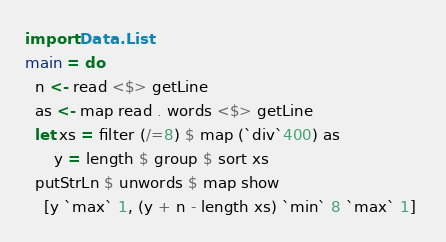Convert code to text. <code><loc_0><loc_0><loc_500><loc_500><_Haskell_>import Data.List
main = do
  n <- read <$> getLine
  as <- map read . words <$> getLine
  let xs = filter (/=8) $ map (`div`400) as
      y = length $ group $ sort xs
  putStrLn $ unwords $ map show 
    [y `max` 1, (y + n - length xs) `min` 8 `max` 1] 
</code> 